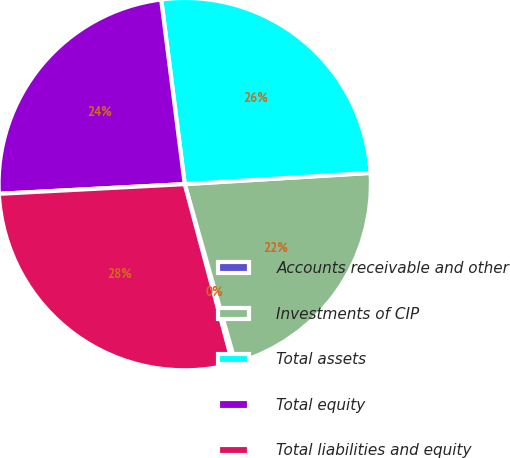Convert chart to OTSL. <chart><loc_0><loc_0><loc_500><loc_500><pie_chart><fcel>Accounts receivable and other<fcel>Investments of CIP<fcel>Total assets<fcel>Total equity<fcel>Total liabilities and equity<nl><fcel>0.25%<fcel>21.56%<fcel>26.06%<fcel>23.81%<fcel>28.32%<nl></chart> 